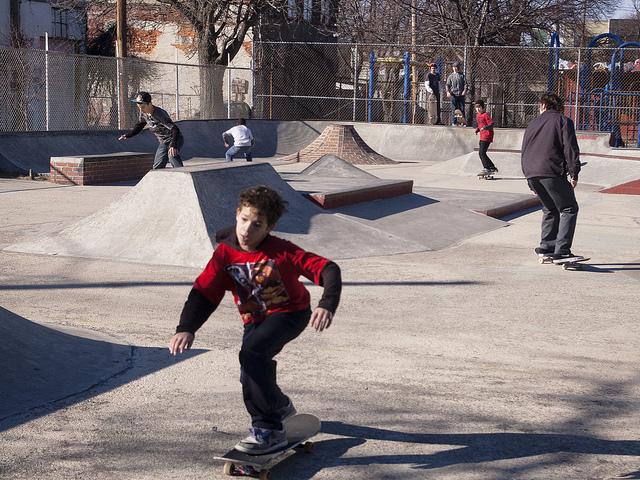What color shirt is the boy in front wearing?
Write a very short answer. Red. Is he skating or walking?
Be succinct. Skating. What type of park is depicted in the photo?
Keep it brief. Skate park. 